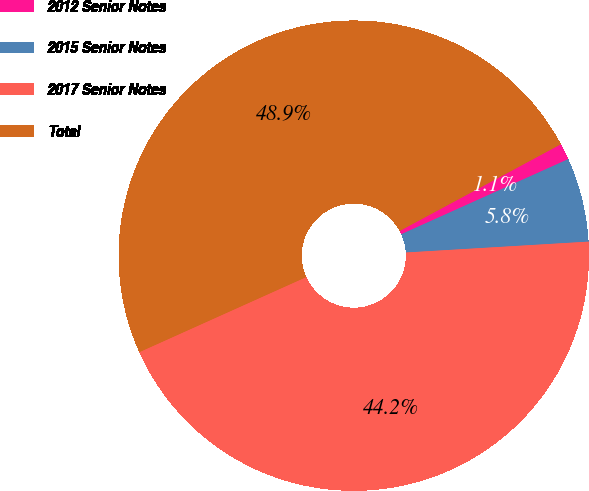<chart> <loc_0><loc_0><loc_500><loc_500><pie_chart><fcel>2012 Senior Notes<fcel>2015 Senior Notes<fcel>2017 Senior Notes<fcel>Total<nl><fcel>1.13%<fcel>5.78%<fcel>44.22%<fcel>48.87%<nl></chart> 